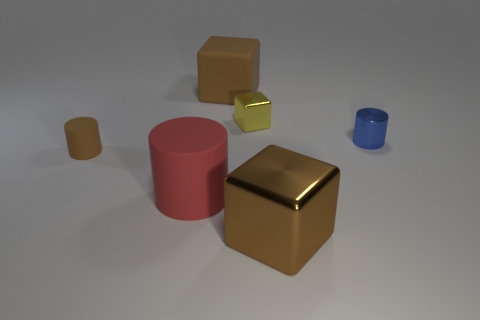Imagine these objects are part of a game, what could be the rules involving these objects? In a hypothetical game involving these objects, the rules could incorporate their shapes and colors. For example, the objective might be to stack objects to form a tower. The player must start with the brown cylinder as a base due to its stability, then add objects of different colors in a specific order, while the reflective gold cube could be a special piece that doubles the points when placed at the top. Each placement must be done carefully to avoid toppling the structure, adding a strategic and dexterity element to the game. 